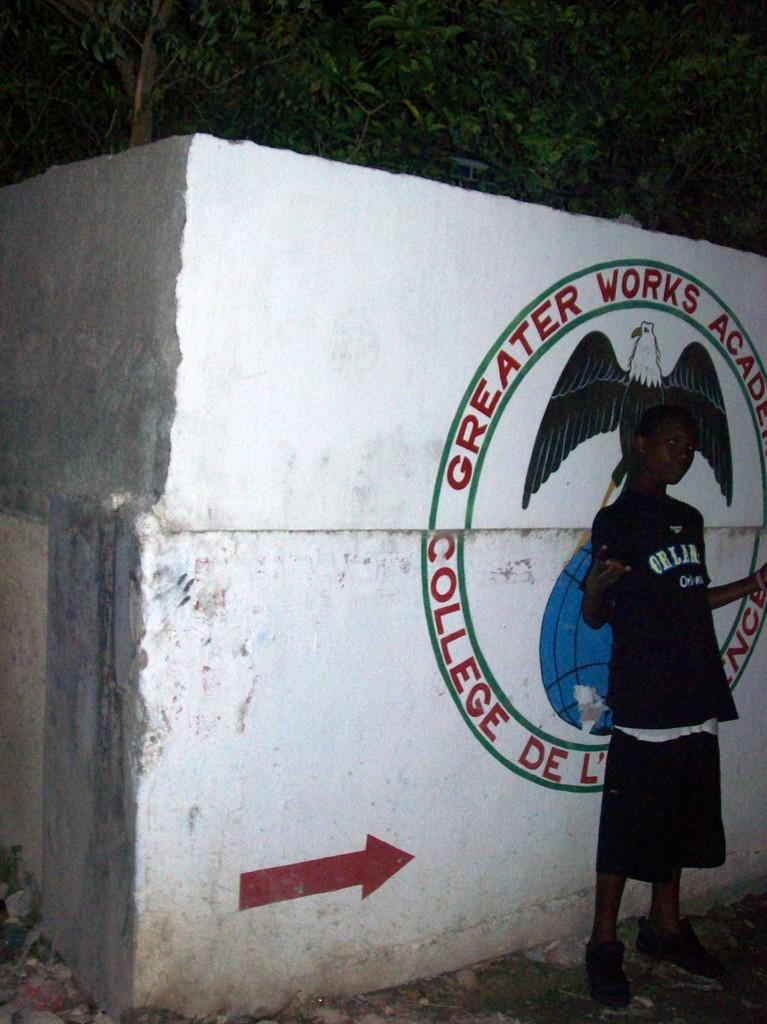<image>
Relay a brief, clear account of the picture shown. A person poses in front of a Greater Works Academy logo. 